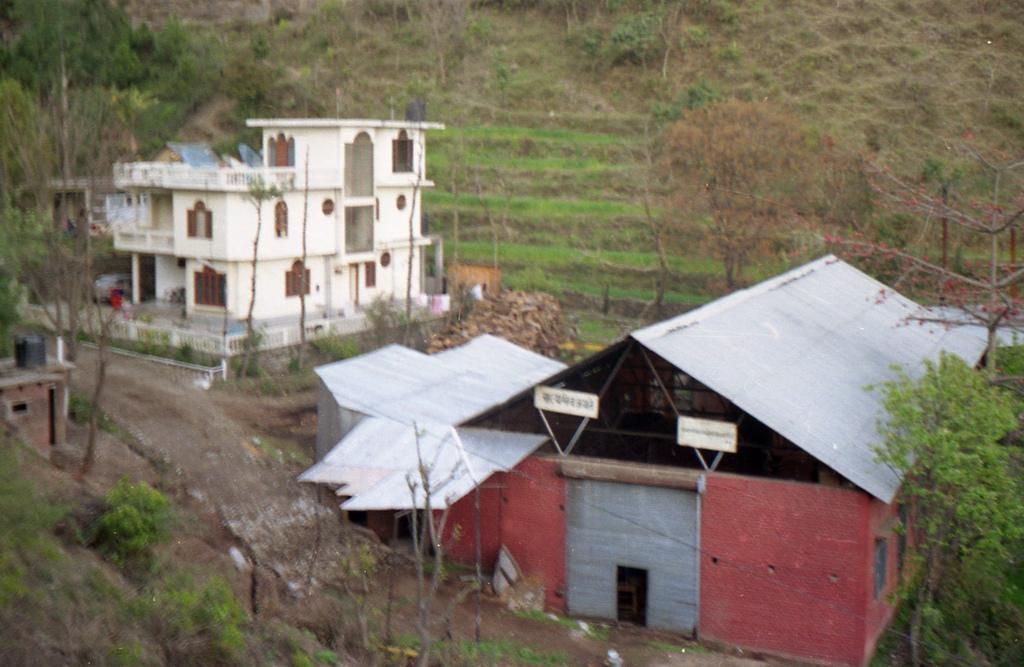What type of vegetation is in the front of the image? There are plants in the front of the image. What structures are located in the center of the image? There are houses in the center of the image. What can be seen in the background of the image? There are trees in the background of the image. What type of metal can be seen on the scale in the image? There is no metal or scale present in the image. How does the drop of water affect the plants in the image? There is no drop of water present in the image, so its effect on the plants cannot be determined. 